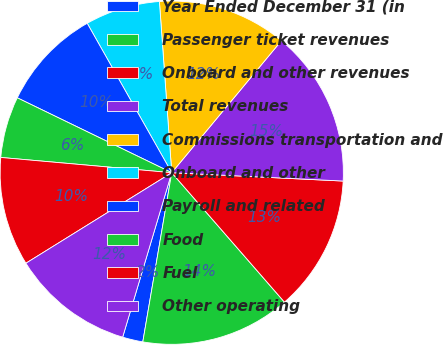<chart> <loc_0><loc_0><loc_500><loc_500><pie_chart><fcel>Year Ended December 31 (in<fcel>Passenger ticket revenues<fcel>Onboard and other revenues<fcel>Total revenues<fcel>Commissions transportation and<fcel>Onboard and other<fcel>Payroll and related<fcel>Food<fcel>Fuel<fcel>Other operating<nl><fcel>1.92%<fcel>14.1%<fcel>12.82%<fcel>14.74%<fcel>12.18%<fcel>7.05%<fcel>9.62%<fcel>5.77%<fcel>10.26%<fcel>11.54%<nl></chart> 